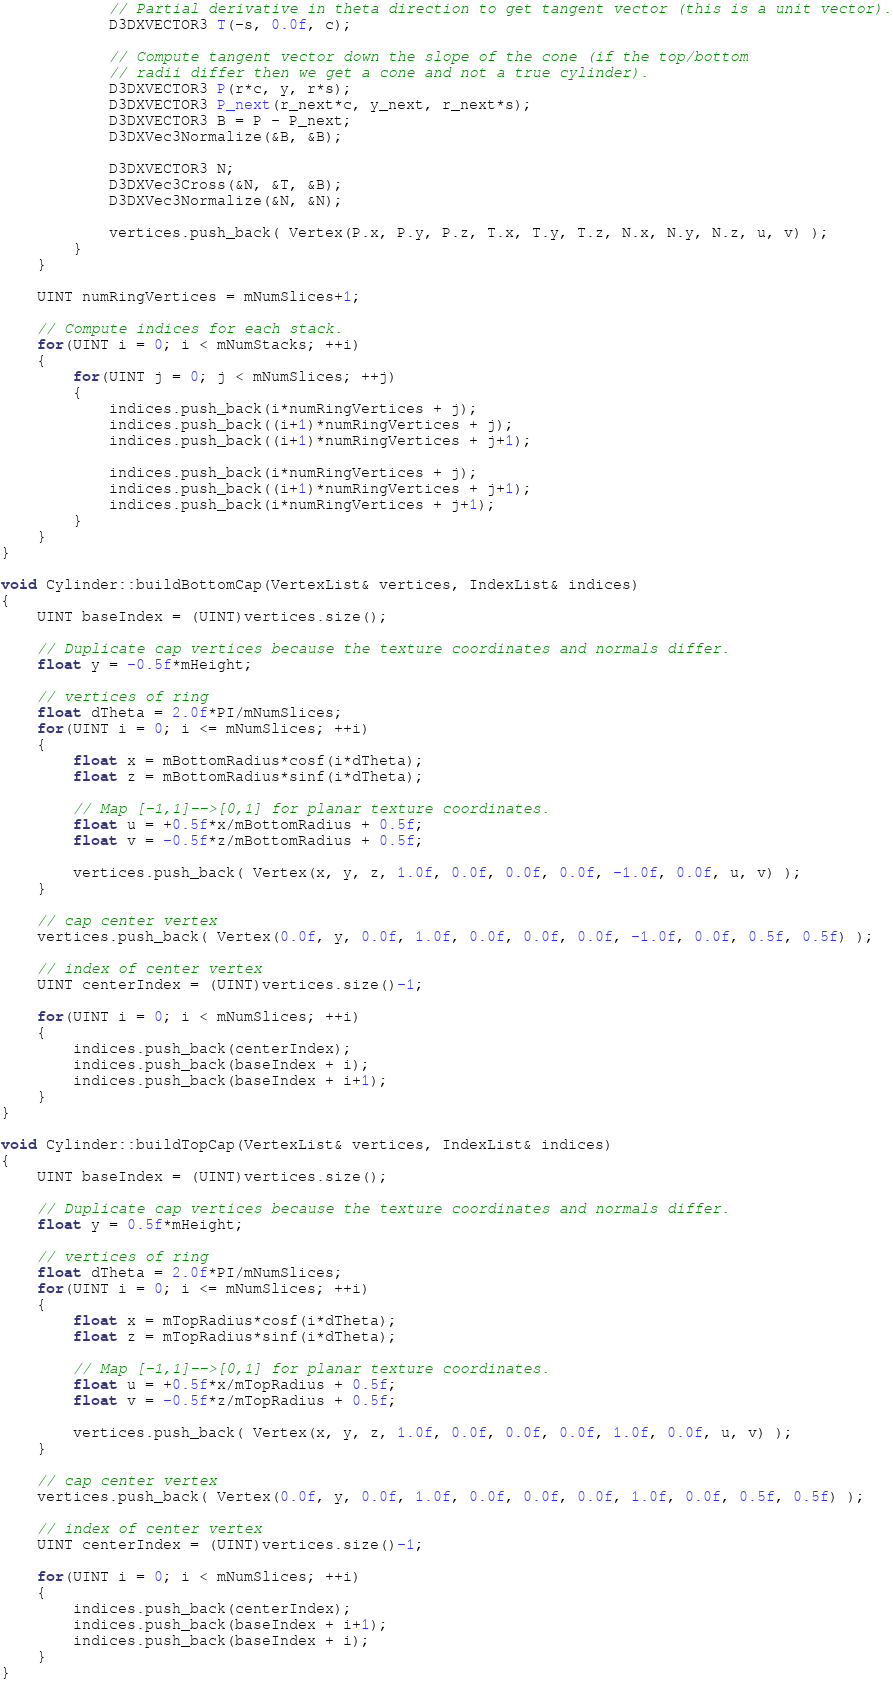<code> <loc_0><loc_0><loc_500><loc_500><_C++_>
			// Partial derivative in theta direction to get tangent vector (this is a unit vector).
			D3DXVECTOR3 T(-s, 0.0f, c);

			// Compute tangent vector down the slope of the cone (if the top/bottom 
			// radii differ then we get a cone and not a true cylinder).
			D3DXVECTOR3 P(r*c, y, r*s);
			D3DXVECTOR3 P_next(r_next*c, y_next, r_next*s);
			D3DXVECTOR3 B = P - P_next;
			D3DXVec3Normalize(&B, &B);

			D3DXVECTOR3 N;
			D3DXVec3Cross(&N, &T, &B);
			D3DXVec3Normalize(&N, &N);

			vertices.push_back( Vertex(P.x, P.y, P.z, T.x, T.y, T.z, N.x, N.y, N.z, u, v) );
		}
	}

	UINT numRingVertices = mNumSlices+1;

	// Compute indices for each stack.
	for(UINT i = 0; i < mNumStacks; ++i)
	{
		for(UINT j = 0; j < mNumSlices; ++j)
		{
			indices.push_back(i*numRingVertices + j);
			indices.push_back((i+1)*numRingVertices + j);
			indices.push_back((i+1)*numRingVertices + j+1);

			indices.push_back(i*numRingVertices + j);
			indices.push_back((i+1)*numRingVertices + j+1);
			indices.push_back(i*numRingVertices + j+1);
		}
	}
}
 
void Cylinder::buildBottomCap(VertexList& vertices, IndexList& indices)
{
	UINT baseIndex = (UINT)vertices.size();

	// Duplicate cap vertices because the texture coordinates and normals differ.
	float y = -0.5f*mHeight;

	// vertices of ring
	float dTheta = 2.0f*PI/mNumSlices;
	for(UINT i = 0; i <= mNumSlices; ++i)
	{
		float x = mBottomRadius*cosf(i*dTheta);
		float z = mBottomRadius*sinf(i*dTheta);

		// Map [-1,1]-->[0,1] for planar texture coordinates.
		float u = +0.5f*x/mBottomRadius + 0.5f;
		float v = -0.5f*z/mBottomRadius + 0.5f;

		vertices.push_back( Vertex(x, y, z, 1.0f, 0.0f, 0.0f, 0.0f, -1.0f, 0.0f, u, v) );
	}

	// cap center vertex
	vertices.push_back( Vertex(0.0f, y, 0.0f, 1.0f, 0.0f, 0.0f, 0.0f, -1.0f, 0.0f, 0.5f, 0.5f) );

	// index of center vertex
	UINT centerIndex = (UINT)vertices.size()-1;

	for(UINT i = 0; i < mNumSlices; ++i)
	{
		indices.push_back(centerIndex);
		indices.push_back(baseIndex + i);
		indices.push_back(baseIndex + i+1);
	}
}

void Cylinder::buildTopCap(VertexList& vertices, IndexList& indices)
{
	UINT baseIndex = (UINT)vertices.size();

	// Duplicate cap vertices because the texture coordinates and normals differ.
	float y = 0.5f*mHeight;

	// vertices of ring
	float dTheta = 2.0f*PI/mNumSlices;
	for(UINT i = 0; i <= mNumSlices; ++i)
	{
		float x = mTopRadius*cosf(i*dTheta);
		float z = mTopRadius*sinf(i*dTheta);

		// Map [-1,1]-->[0,1] for planar texture coordinates.
		float u = +0.5f*x/mTopRadius + 0.5f;
		float v = -0.5f*z/mTopRadius + 0.5f;

		vertices.push_back( Vertex(x, y, z, 1.0f, 0.0f, 0.0f, 0.0f, 1.0f, 0.0f, u, v) );
	}

	// cap center vertex
	vertices.push_back( Vertex(0.0f, y, 0.0f, 1.0f, 0.0f, 0.0f, 0.0f, 1.0f, 0.0f, 0.5f, 0.5f) );

	// index of center vertex
	UINT centerIndex = (UINT)vertices.size()-1;

	for(UINT i = 0; i < mNumSlices; ++i)
	{
		indices.push_back(centerIndex);
		indices.push_back(baseIndex + i+1);
		indices.push_back(baseIndex + i);
	}
}</code> 